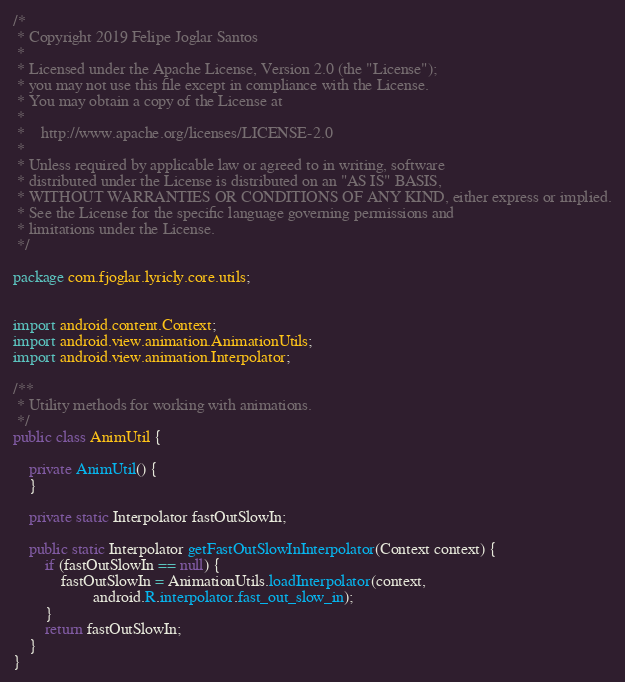<code> <loc_0><loc_0><loc_500><loc_500><_Java_>/*
 * Copyright 2019 Felipe Joglar Santos
 *
 * Licensed under the Apache License, Version 2.0 (the "License");
 * you may not use this file except in compliance with the License.
 * You may obtain a copy of the License at
 *
 *    http://www.apache.org/licenses/LICENSE-2.0
 *
 * Unless required by applicable law or agreed to in writing, software
 * distributed under the License is distributed on an "AS IS" BASIS,
 * WITHOUT WARRANTIES OR CONDITIONS OF ANY KIND, either express or implied.
 * See the License for the specific language governing permissions and
 * limitations under the License.
 */

package com.fjoglar.lyricly.core.utils;


import android.content.Context;
import android.view.animation.AnimationUtils;
import android.view.animation.Interpolator;

/**
 * Utility methods for working with animations.
 */
public class AnimUtil {

    private AnimUtil() {
    }

    private static Interpolator fastOutSlowIn;

    public static Interpolator getFastOutSlowInInterpolator(Context context) {
        if (fastOutSlowIn == null) {
            fastOutSlowIn = AnimationUtils.loadInterpolator(context,
                    android.R.interpolator.fast_out_slow_in);
        }
        return fastOutSlowIn;
    }
}
</code> 